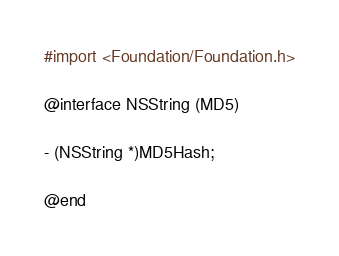Convert code to text. <code><loc_0><loc_0><loc_500><loc_500><_C_>#import <Foundation/Foundation.h>

@interface NSString (MD5)

- (NSString *)MD5Hash;

@end
</code> 